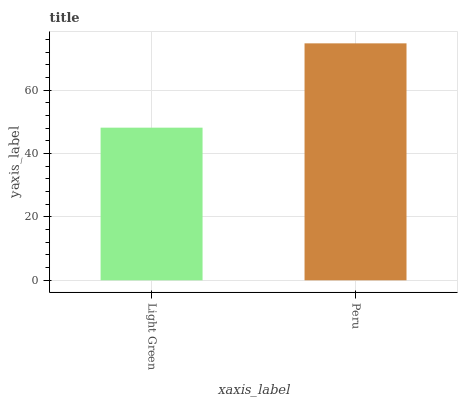Is Light Green the minimum?
Answer yes or no. Yes. Is Peru the maximum?
Answer yes or no. Yes. Is Peru the minimum?
Answer yes or no. No. Is Peru greater than Light Green?
Answer yes or no. Yes. Is Light Green less than Peru?
Answer yes or no. Yes. Is Light Green greater than Peru?
Answer yes or no. No. Is Peru less than Light Green?
Answer yes or no. No. Is Peru the high median?
Answer yes or no. Yes. Is Light Green the low median?
Answer yes or no. Yes. Is Light Green the high median?
Answer yes or no. No. Is Peru the low median?
Answer yes or no. No. 